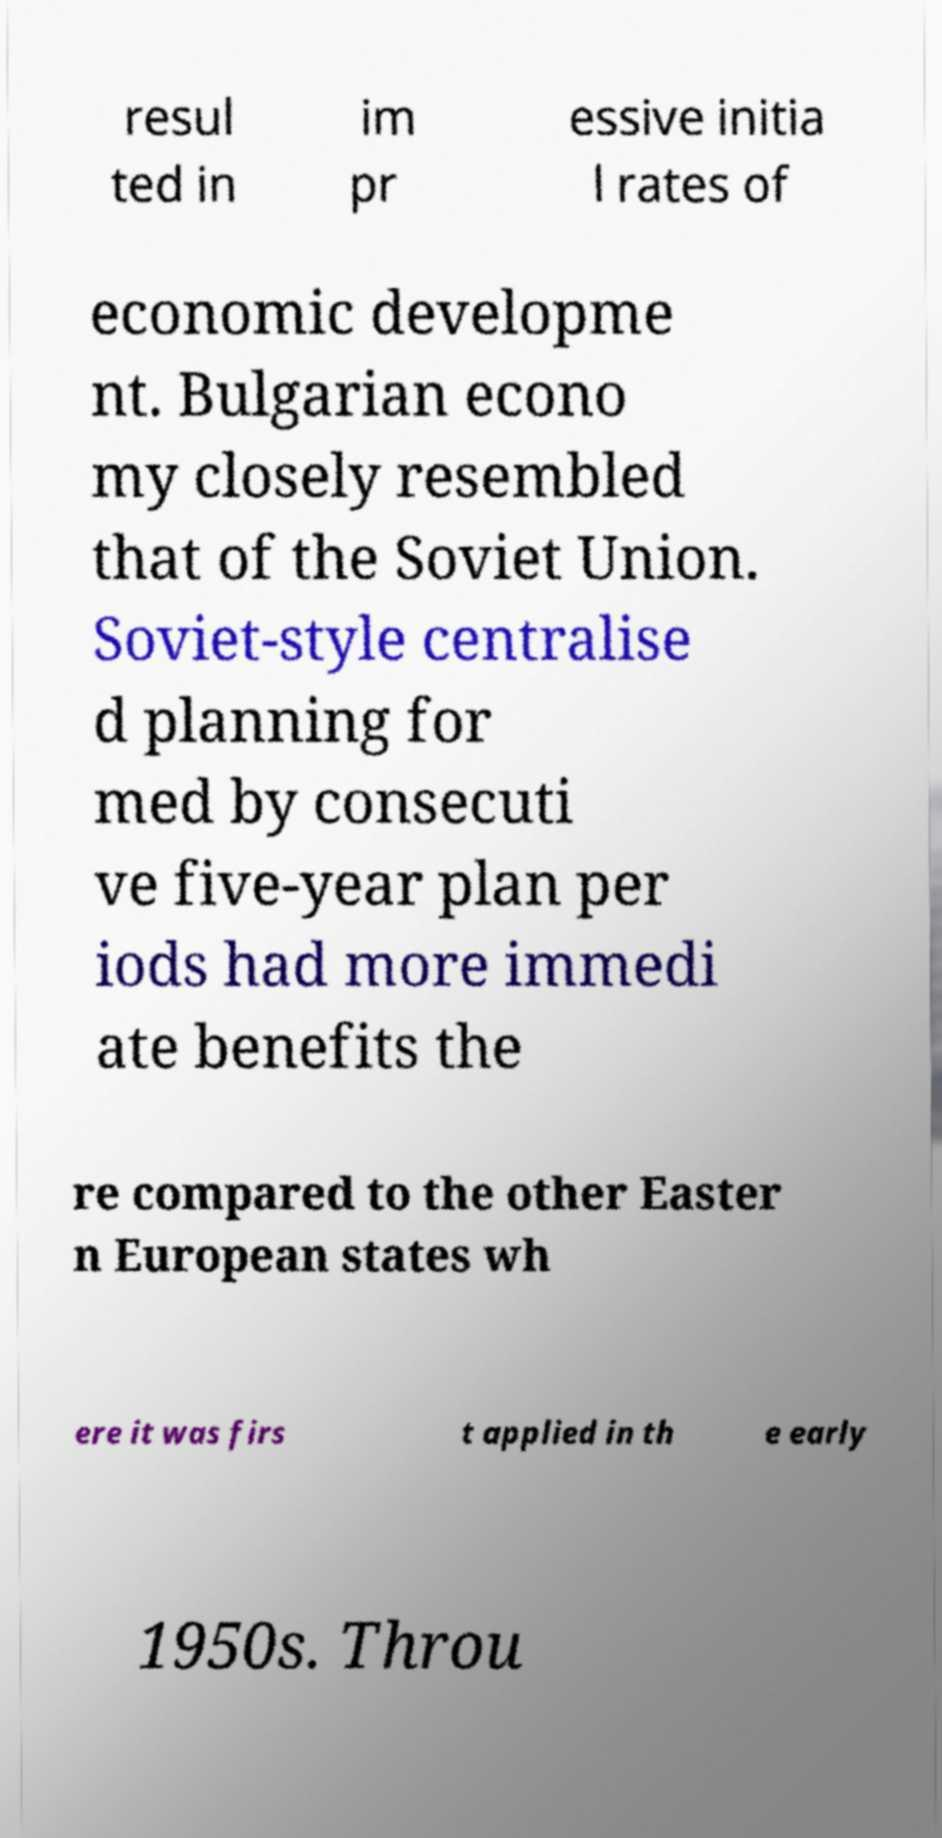Please identify and transcribe the text found in this image. resul ted in im pr essive initia l rates of economic developme nt. Bulgarian econo my closely resembled that of the Soviet Union. Soviet-style centralise d planning for med by consecuti ve five-year plan per iods had more immedi ate benefits the re compared to the other Easter n European states wh ere it was firs t applied in th e early 1950s. Throu 